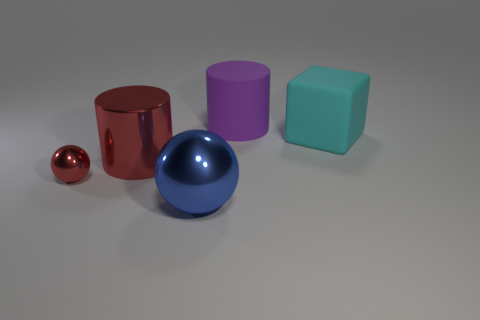Subtract 2 cylinders. How many cylinders are left? 0 Add 3 cyan cubes. How many cyan cubes exist? 4 Add 2 big cylinders. How many objects exist? 7 Subtract 0 gray spheres. How many objects are left? 5 Subtract all cylinders. How many objects are left? 3 Subtract all red blocks. Subtract all brown cylinders. How many blocks are left? 1 Subtract all green balls. How many yellow cylinders are left? 0 Subtract all small gray metal blocks. Subtract all big rubber objects. How many objects are left? 3 Add 4 blue objects. How many blue objects are left? 5 